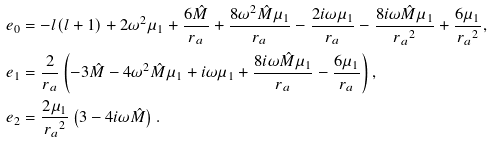Convert formula to latex. <formula><loc_0><loc_0><loc_500><loc_500>e _ { 0 } & = - l ( l + 1 ) + 2 \omega ^ { 2 } \mu _ { 1 } + \frac { 6 \hat { M } } { r _ { a } } + \frac { 8 \omega ^ { 2 } \hat { M } \mu _ { 1 } } { r _ { a } } - \frac { 2 i \omega \mu _ { 1 } } { r _ { a } } - \frac { 8 i \omega \hat { M } \mu _ { 1 } } { { r _ { a } } ^ { 2 } } + \frac { 6 \mu _ { 1 } } { { r _ { a } } ^ { 2 } } , \\ e _ { 1 } & = \frac { 2 } { r _ { a } } \left ( - 3 \hat { M } - 4 \omega ^ { 2 } \hat { M } \mu _ { 1 } + i \omega \mu _ { 1 } + \frac { 8 i \omega \hat { M } \mu _ { 1 } } { r _ { a } } - \frac { 6 \mu _ { 1 } } { r _ { a } } \right ) , \\ e _ { 2 } & = \frac { 2 \mu _ { 1 } } { { r _ { a } } ^ { 2 } } \left ( 3 - 4 i \omega \hat { M } \right ) .</formula> 